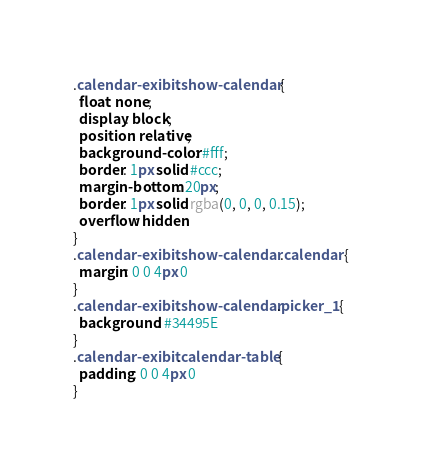Convert code to text. <code><loc_0><loc_0><loc_500><loc_500><_CSS_>.calendar-exibit .show-calendar {
  float: none;
  display: block;
  position: relative;
  background-color: #fff;
  border: 1px solid #ccc;
  margin-bottom: 20px;
  border: 1px solid rgba(0, 0, 0, 0.15);
  overflow: hidden
}
.calendar-exibit .show-calendar .calendar {
  margin: 0 0 4px 0
}
.calendar-exibit .show-calendar.picker_1 {
  background: #34495E
}
.calendar-exibit .calendar-table {
  padding: 0 0 4px 0
}
</code> 